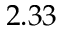<formula> <loc_0><loc_0><loc_500><loc_500>2 . 3 3</formula> 